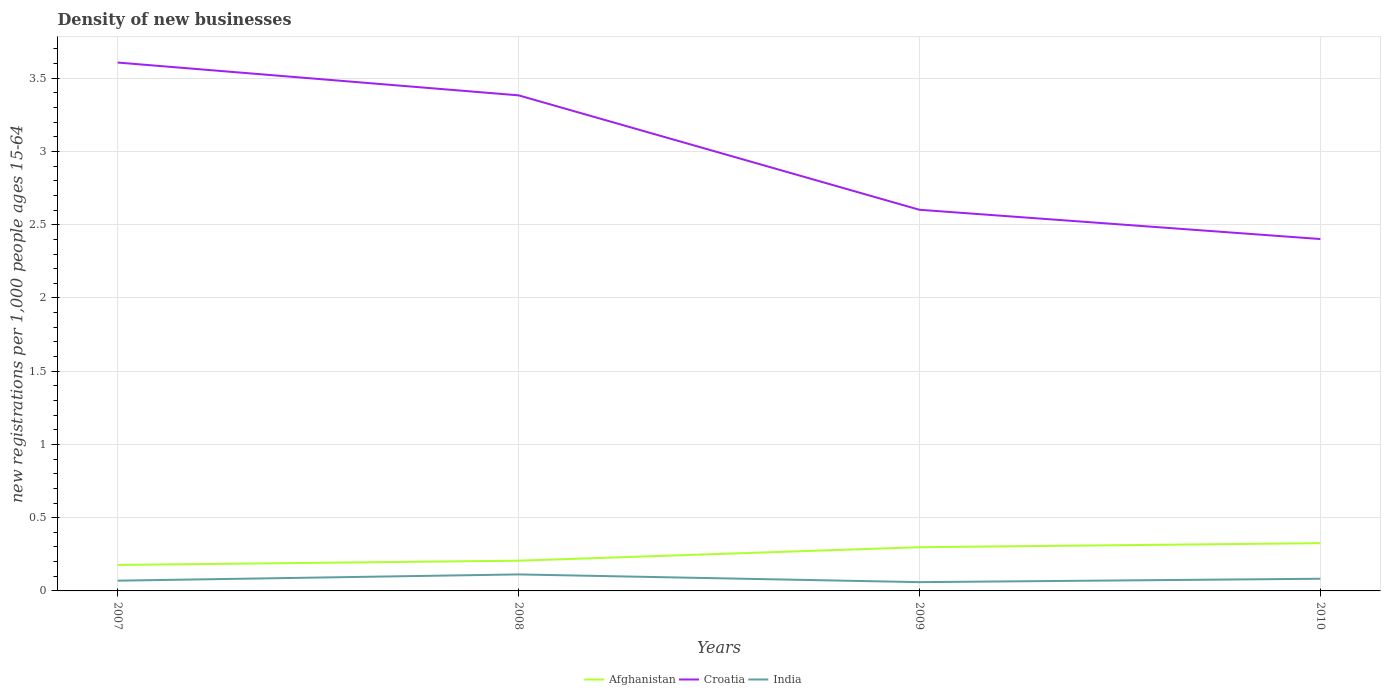Is the number of lines equal to the number of legend labels?
Your answer should be very brief. Yes. Across all years, what is the maximum number of new registrations in Croatia?
Ensure brevity in your answer.  2.4. In which year was the number of new registrations in India maximum?
Offer a very short reply. 2009. What is the total number of new registrations in Croatia in the graph?
Your answer should be compact. 0.2. What is the difference between the highest and the second highest number of new registrations in Afghanistan?
Your answer should be very brief. 0.15. What is the difference between the highest and the lowest number of new registrations in Croatia?
Make the answer very short. 2. How many lines are there?
Your answer should be very brief. 3. How many years are there in the graph?
Your answer should be very brief. 4. What is the difference between two consecutive major ticks on the Y-axis?
Your response must be concise. 0.5. Does the graph contain grids?
Offer a terse response. Yes. Where does the legend appear in the graph?
Ensure brevity in your answer.  Bottom center. How many legend labels are there?
Make the answer very short. 3. What is the title of the graph?
Give a very brief answer. Density of new businesses. What is the label or title of the X-axis?
Provide a succinct answer. Years. What is the label or title of the Y-axis?
Give a very brief answer. New registrations per 1,0 people ages 15-64. What is the new registrations per 1,000 people ages 15-64 of Afghanistan in 2007?
Give a very brief answer. 0.18. What is the new registrations per 1,000 people ages 15-64 of Croatia in 2007?
Make the answer very short. 3.61. What is the new registrations per 1,000 people ages 15-64 of India in 2007?
Ensure brevity in your answer.  0.07. What is the new registrations per 1,000 people ages 15-64 in Afghanistan in 2008?
Give a very brief answer. 0.21. What is the new registrations per 1,000 people ages 15-64 in Croatia in 2008?
Your answer should be very brief. 3.38. What is the new registrations per 1,000 people ages 15-64 in India in 2008?
Make the answer very short. 0.11. What is the new registrations per 1,000 people ages 15-64 in Afghanistan in 2009?
Ensure brevity in your answer.  0.3. What is the new registrations per 1,000 people ages 15-64 of Croatia in 2009?
Offer a terse response. 2.6. What is the new registrations per 1,000 people ages 15-64 of India in 2009?
Provide a short and direct response. 0.06. What is the new registrations per 1,000 people ages 15-64 in Afghanistan in 2010?
Make the answer very short. 0.33. What is the new registrations per 1,000 people ages 15-64 of Croatia in 2010?
Keep it short and to the point. 2.4. What is the new registrations per 1,000 people ages 15-64 of India in 2010?
Offer a terse response. 0.08. Across all years, what is the maximum new registrations per 1,000 people ages 15-64 in Afghanistan?
Make the answer very short. 0.33. Across all years, what is the maximum new registrations per 1,000 people ages 15-64 of Croatia?
Ensure brevity in your answer.  3.61. Across all years, what is the maximum new registrations per 1,000 people ages 15-64 in India?
Ensure brevity in your answer.  0.11. Across all years, what is the minimum new registrations per 1,000 people ages 15-64 in Afghanistan?
Offer a terse response. 0.18. Across all years, what is the minimum new registrations per 1,000 people ages 15-64 of Croatia?
Offer a terse response. 2.4. Across all years, what is the minimum new registrations per 1,000 people ages 15-64 of India?
Offer a terse response. 0.06. What is the total new registrations per 1,000 people ages 15-64 in Afghanistan in the graph?
Your response must be concise. 1.01. What is the total new registrations per 1,000 people ages 15-64 in Croatia in the graph?
Offer a very short reply. 11.99. What is the total new registrations per 1,000 people ages 15-64 of India in the graph?
Offer a very short reply. 0.33. What is the difference between the new registrations per 1,000 people ages 15-64 in Afghanistan in 2007 and that in 2008?
Offer a terse response. -0.03. What is the difference between the new registrations per 1,000 people ages 15-64 of Croatia in 2007 and that in 2008?
Provide a succinct answer. 0.22. What is the difference between the new registrations per 1,000 people ages 15-64 in India in 2007 and that in 2008?
Provide a succinct answer. -0.04. What is the difference between the new registrations per 1,000 people ages 15-64 of Afghanistan in 2007 and that in 2009?
Provide a short and direct response. -0.12. What is the difference between the new registrations per 1,000 people ages 15-64 in Croatia in 2007 and that in 2009?
Offer a very short reply. 1. What is the difference between the new registrations per 1,000 people ages 15-64 in Afghanistan in 2007 and that in 2010?
Make the answer very short. -0.15. What is the difference between the new registrations per 1,000 people ages 15-64 of Croatia in 2007 and that in 2010?
Ensure brevity in your answer.  1.2. What is the difference between the new registrations per 1,000 people ages 15-64 of India in 2007 and that in 2010?
Your answer should be compact. -0.01. What is the difference between the new registrations per 1,000 people ages 15-64 in Afghanistan in 2008 and that in 2009?
Keep it short and to the point. -0.09. What is the difference between the new registrations per 1,000 people ages 15-64 in Croatia in 2008 and that in 2009?
Your answer should be compact. 0.78. What is the difference between the new registrations per 1,000 people ages 15-64 in India in 2008 and that in 2009?
Offer a very short reply. 0.05. What is the difference between the new registrations per 1,000 people ages 15-64 of Afghanistan in 2008 and that in 2010?
Your answer should be compact. -0.12. What is the difference between the new registrations per 1,000 people ages 15-64 of India in 2008 and that in 2010?
Your response must be concise. 0.03. What is the difference between the new registrations per 1,000 people ages 15-64 of Afghanistan in 2009 and that in 2010?
Provide a succinct answer. -0.03. What is the difference between the new registrations per 1,000 people ages 15-64 of Croatia in 2009 and that in 2010?
Your answer should be very brief. 0.2. What is the difference between the new registrations per 1,000 people ages 15-64 of India in 2009 and that in 2010?
Your response must be concise. -0.02. What is the difference between the new registrations per 1,000 people ages 15-64 in Afghanistan in 2007 and the new registrations per 1,000 people ages 15-64 in Croatia in 2008?
Ensure brevity in your answer.  -3.21. What is the difference between the new registrations per 1,000 people ages 15-64 of Afghanistan in 2007 and the new registrations per 1,000 people ages 15-64 of India in 2008?
Offer a very short reply. 0.06. What is the difference between the new registrations per 1,000 people ages 15-64 in Croatia in 2007 and the new registrations per 1,000 people ages 15-64 in India in 2008?
Provide a succinct answer. 3.49. What is the difference between the new registrations per 1,000 people ages 15-64 in Afghanistan in 2007 and the new registrations per 1,000 people ages 15-64 in Croatia in 2009?
Provide a short and direct response. -2.42. What is the difference between the new registrations per 1,000 people ages 15-64 of Afghanistan in 2007 and the new registrations per 1,000 people ages 15-64 of India in 2009?
Provide a short and direct response. 0.12. What is the difference between the new registrations per 1,000 people ages 15-64 in Croatia in 2007 and the new registrations per 1,000 people ages 15-64 in India in 2009?
Your answer should be compact. 3.55. What is the difference between the new registrations per 1,000 people ages 15-64 of Afghanistan in 2007 and the new registrations per 1,000 people ages 15-64 of Croatia in 2010?
Make the answer very short. -2.22. What is the difference between the new registrations per 1,000 people ages 15-64 of Afghanistan in 2007 and the new registrations per 1,000 people ages 15-64 of India in 2010?
Provide a short and direct response. 0.09. What is the difference between the new registrations per 1,000 people ages 15-64 of Croatia in 2007 and the new registrations per 1,000 people ages 15-64 of India in 2010?
Your answer should be compact. 3.52. What is the difference between the new registrations per 1,000 people ages 15-64 in Afghanistan in 2008 and the new registrations per 1,000 people ages 15-64 in Croatia in 2009?
Your response must be concise. -2.4. What is the difference between the new registrations per 1,000 people ages 15-64 in Afghanistan in 2008 and the new registrations per 1,000 people ages 15-64 in India in 2009?
Provide a short and direct response. 0.15. What is the difference between the new registrations per 1,000 people ages 15-64 in Croatia in 2008 and the new registrations per 1,000 people ages 15-64 in India in 2009?
Your answer should be very brief. 3.32. What is the difference between the new registrations per 1,000 people ages 15-64 in Afghanistan in 2008 and the new registrations per 1,000 people ages 15-64 in Croatia in 2010?
Provide a succinct answer. -2.2. What is the difference between the new registrations per 1,000 people ages 15-64 of Afghanistan in 2008 and the new registrations per 1,000 people ages 15-64 of India in 2010?
Provide a short and direct response. 0.12. What is the difference between the new registrations per 1,000 people ages 15-64 of Croatia in 2008 and the new registrations per 1,000 people ages 15-64 of India in 2010?
Your answer should be very brief. 3.3. What is the difference between the new registrations per 1,000 people ages 15-64 of Afghanistan in 2009 and the new registrations per 1,000 people ages 15-64 of Croatia in 2010?
Provide a succinct answer. -2.1. What is the difference between the new registrations per 1,000 people ages 15-64 of Afghanistan in 2009 and the new registrations per 1,000 people ages 15-64 of India in 2010?
Your response must be concise. 0.22. What is the difference between the new registrations per 1,000 people ages 15-64 of Croatia in 2009 and the new registrations per 1,000 people ages 15-64 of India in 2010?
Offer a terse response. 2.52. What is the average new registrations per 1,000 people ages 15-64 of Afghanistan per year?
Ensure brevity in your answer.  0.25. What is the average new registrations per 1,000 people ages 15-64 in Croatia per year?
Provide a short and direct response. 3. What is the average new registrations per 1,000 people ages 15-64 of India per year?
Make the answer very short. 0.08. In the year 2007, what is the difference between the new registrations per 1,000 people ages 15-64 of Afghanistan and new registrations per 1,000 people ages 15-64 of Croatia?
Offer a terse response. -3.43. In the year 2007, what is the difference between the new registrations per 1,000 people ages 15-64 of Afghanistan and new registrations per 1,000 people ages 15-64 of India?
Ensure brevity in your answer.  0.11. In the year 2007, what is the difference between the new registrations per 1,000 people ages 15-64 of Croatia and new registrations per 1,000 people ages 15-64 of India?
Make the answer very short. 3.54. In the year 2008, what is the difference between the new registrations per 1,000 people ages 15-64 of Afghanistan and new registrations per 1,000 people ages 15-64 of Croatia?
Your answer should be compact. -3.18. In the year 2008, what is the difference between the new registrations per 1,000 people ages 15-64 of Afghanistan and new registrations per 1,000 people ages 15-64 of India?
Keep it short and to the point. 0.09. In the year 2008, what is the difference between the new registrations per 1,000 people ages 15-64 in Croatia and new registrations per 1,000 people ages 15-64 in India?
Give a very brief answer. 3.27. In the year 2009, what is the difference between the new registrations per 1,000 people ages 15-64 of Afghanistan and new registrations per 1,000 people ages 15-64 of Croatia?
Your answer should be very brief. -2.3. In the year 2009, what is the difference between the new registrations per 1,000 people ages 15-64 of Afghanistan and new registrations per 1,000 people ages 15-64 of India?
Give a very brief answer. 0.24. In the year 2009, what is the difference between the new registrations per 1,000 people ages 15-64 of Croatia and new registrations per 1,000 people ages 15-64 of India?
Ensure brevity in your answer.  2.54. In the year 2010, what is the difference between the new registrations per 1,000 people ages 15-64 of Afghanistan and new registrations per 1,000 people ages 15-64 of Croatia?
Provide a succinct answer. -2.08. In the year 2010, what is the difference between the new registrations per 1,000 people ages 15-64 in Afghanistan and new registrations per 1,000 people ages 15-64 in India?
Your response must be concise. 0.24. In the year 2010, what is the difference between the new registrations per 1,000 people ages 15-64 of Croatia and new registrations per 1,000 people ages 15-64 of India?
Keep it short and to the point. 2.32. What is the ratio of the new registrations per 1,000 people ages 15-64 of Afghanistan in 2007 to that in 2008?
Give a very brief answer. 0.86. What is the ratio of the new registrations per 1,000 people ages 15-64 of Croatia in 2007 to that in 2008?
Ensure brevity in your answer.  1.07. What is the ratio of the new registrations per 1,000 people ages 15-64 of India in 2007 to that in 2008?
Keep it short and to the point. 0.62. What is the ratio of the new registrations per 1,000 people ages 15-64 in Afghanistan in 2007 to that in 2009?
Keep it short and to the point. 0.59. What is the ratio of the new registrations per 1,000 people ages 15-64 in Croatia in 2007 to that in 2009?
Your answer should be compact. 1.39. What is the ratio of the new registrations per 1,000 people ages 15-64 in India in 2007 to that in 2009?
Make the answer very short. 1.17. What is the ratio of the new registrations per 1,000 people ages 15-64 of Afghanistan in 2007 to that in 2010?
Your answer should be compact. 0.54. What is the ratio of the new registrations per 1,000 people ages 15-64 in Croatia in 2007 to that in 2010?
Provide a short and direct response. 1.5. What is the ratio of the new registrations per 1,000 people ages 15-64 in India in 2007 to that in 2010?
Give a very brief answer. 0.84. What is the ratio of the new registrations per 1,000 people ages 15-64 in Afghanistan in 2008 to that in 2009?
Your response must be concise. 0.69. What is the ratio of the new registrations per 1,000 people ages 15-64 in Croatia in 2008 to that in 2009?
Your answer should be very brief. 1.3. What is the ratio of the new registrations per 1,000 people ages 15-64 in India in 2008 to that in 2009?
Make the answer very short. 1.88. What is the ratio of the new registrations per 1,000 people ages 15-64 in Afghanistan in 2008 to that in 2010?
Give a very brief answer. 0.63. What is the ratio of the new registrations per 1,000 people ages 15-64 of Croatia in 2008 to that in 2010?
Offer a terse response. 1.41. What is the ratio of the new registrations per 1,000 people ages 15-64 of India in 2008 to that in 2010?
Your answer should be compact. 1.35. What is the ratio of the new registrations per 1,000 people ages 15-64 in Afghanistan in 2009 to that in 2010?
Provide a short and direct response. 0.92. What is the ratio of the new registrations per 1,000 people ages 15-64 of Croatia in 2009 to that in 2010?
Your answer should be very brief. 1.08. What is the ratio of the new registrations per 1,000 people ages 15-64 in India in 2009 to that in 2010?
Make the answer very short. 0.72. What is the difference between the highest and the second highest new registrations per 1,000 people ages 15-64 of Afghanistan?
Ensure brevity in your answer.  0.03. What is the difference between the highest and the second highest new registrations per 1,000 people ages 15-64 of Croatia?
Ensure brevity in your answer.  0.22. What is the difference between the highest and the second highest new registrations per 1,000 people ages 15-64 in India?
Provide a succinct answer. 0.03. What is the difference between the highest and the lowest new registrations per 1,000 people ages 15-64 of Afghanistan?
Provide a succinct answer. 0.15. What is the difference between the highest and the lowest new registrations per 1,000 people ages 15-64 in Croatia?
Provide a short and direct response. 1.2. What is the difference between the highest and the lowest new registrations per 1,000 people ages 15-64 in India?
Offer a very short reply. 0.05. 